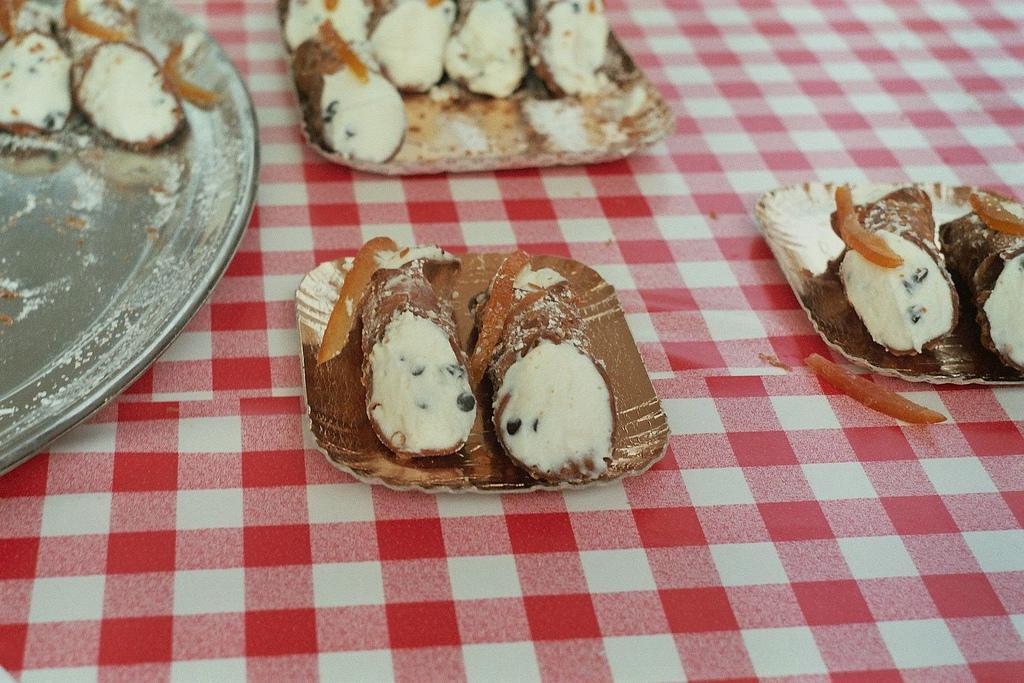In one or two sentences, can you explain what this image depicts? In this image we can see a table with check cloth. On the table there are paper plates with food item. Also there is another plate with food item. 